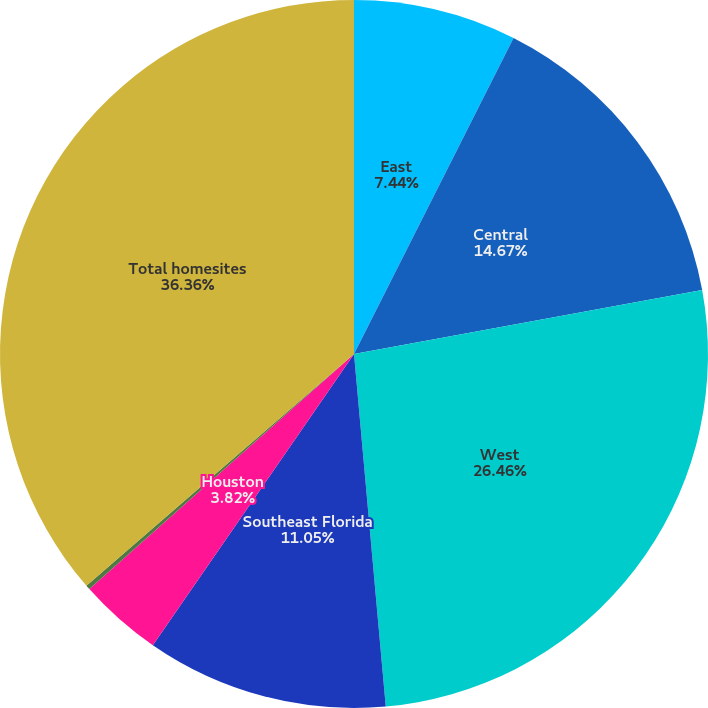Convert chart. <chart><loc_0><loc_0><loc_500><loc_500><pie_chart><fcel>East<fcel>Central<fcel>West<fcel>Southeast Florida<fcel>Houston<fcel>Other<fcel>Total homesites<nl><fcel>7.44%<fcel>14.67%<fcel>26.46%<fcel>11.05%<fcel>3.82%<fcel>0.2%<fcel>36.36%<nl></chart> 